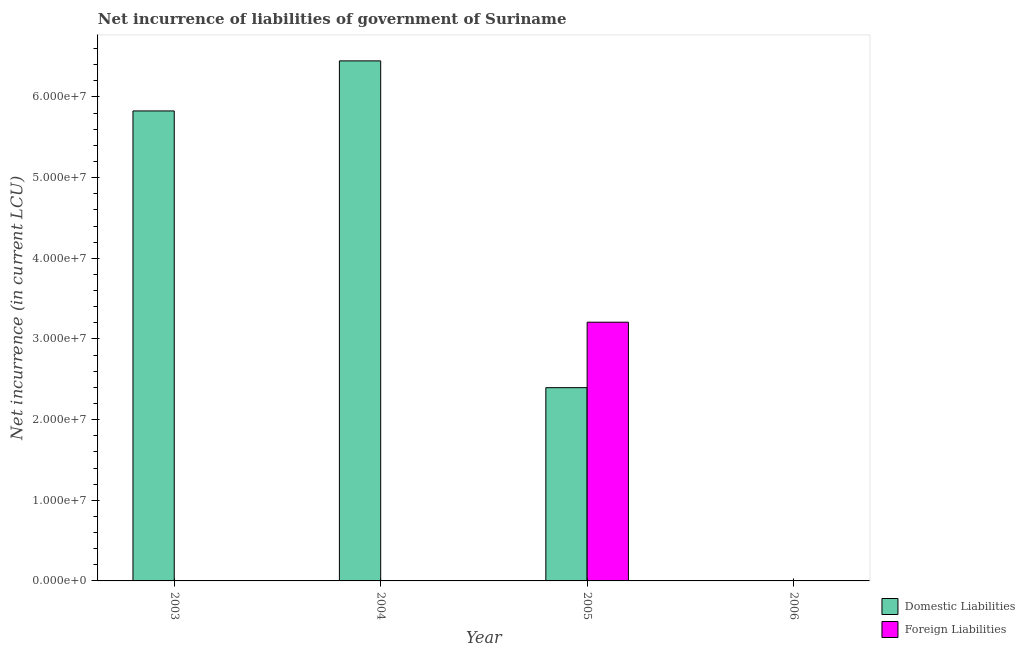What is the label of the 1st group of bars from the left?
Provide a succinct answer. 2003. What is the net incurrence of foreign liabilities in 2004?
Keep it short and to the point. 0. Across all years, what is the maximum net incurrence of domestic liabilities?
Your answer should be very brief. 6.45e+07. Across all years, what is the minimum net incurrence of domestic liabilities?
Your answer should be compact. 0. In which year was the net incurrence of foreign liabilities maximum?
Offer a very short reply. 2005. What is the total net incurrence of foreign liabilities in the graph?
Your response must be concise. 3.21e+07. What is the difference between the net incurrence of domestic liabilities in 2003 and that in 2004?
Your answer should be very brief. -6.21e+06. What is the difference between the net incurrence of domestic liabilities in 2006 and the net incurrence of foreign liabilities in 2004?
Your answer should be compact. -6.45e+07. What is the average net incurrence of domestic liabilities per year?
Make the answer very short. 3.67e+07. In the year 2003, what is the difference between the net incurrence of domestic liabilities and net incurrence of foreign liabilities?
Your answer should be very brief. 0. What is the ratio of the net incurrence of domestic liabilities in 2004 to that in 2005?
Make the answer very short. 2.69. Is the difference between the net incurrence of domestic liabilities in 2003 and 2005 greater than the difference between the net incurrence of foreign liabilities in 2003 and 2005?
Your answer should be compact. No. What is the difference between the highest and the second highest net incurrence of domestic liabilities?
Make the answer very short. 6.21e+06. What is the difference between the highest and the lowest net incurrence of foreign liabilities?
Provide a succinct answer. 3.21e+07. How many bars are there?
Your answer should be very brief. 4. How many years are there in the graph?
Give a very brief answer. 4. Does the graph contain grids?
Provide a succinct answer. No. How many legend labels are there?
Provide a short and direct response. 2. How are the legend labels stacked?
Your answer should be very brief. Vertical. What is the title of the graph?
Give a very brief answer. Net incurrence of liabilities of government of Suriname. Does "Netherlands" appear as one of the legend labels in the graph?
Your response must be concise. No. What is the label or title of the X-axis?
Make the answer very short. Year. What is the label or title of the Y-axis?
Give a very brief answer. Net incurrence (in current LCU). What is the Net incurrence (in current LCU) in Domestic Liabilities in 2003?
Your answer should be very brief. 5.83e+07. What is the Net incurrence (in current LCU) of Foreign Liabilities in 2003?
Offer a very short reply. 0. What is the Net incurrence (in current LCU) in Domestic Liabilities in 2004?
Keep it short and to the point. 6.45e+07. What is the Net incurrence (in current LCU) of Foreign Liabilities in 2004?
Your answer should be very brief. 0. What is the Net incurrence (in current LCU) of Domestic Liabilities in 2005?
Provide a succinct answer. 2.40e+07. What is the Net incurrence (in current LCU) of Foreign Liabilities in 2005?
Your answer should be very brief. 3.21e+07. What is the Net incurrence (in current LCU) in Foreign Liabilities in 2006?
Make the answer very short. 0. Across all years, what is the maximum Net incurrence (in current LCU) of Domestic Liabilities?
Your response must be concise. 6.45e+07. Across all years, what is the maximum Net incurrence (in current LCU) in Foreign Liabilities?
Provide a short and direct response. 3.21e+07. Across all years, what is the minimum Net incurrence (in current LCU) of Foreign Liabilities?
Ensure brevity in your answer.  0. What is the total Net incurrence (in current LCU) of Domestic Liabilities in the graph?
Offer a very short reply. 1.47e+08. What is the total Net incurrence (in current LCU) of Foreign Liabilities in the graph?
Give a very brief answer. 3.21e+07. What is the difference between the Net incurrence (in current LCU) of Domestic Liabilities in 2003 and that in 2004?
Give a very brief answer. -6.21e+06. What is the difference between the Net incurrence (in current LCU) in Domestic Liabilities in 2003 and that in 2005?
Your response must be concise. 3.43e+07. What is the difference between the Net incurrence (in current LCU) in Domestic Liabilities in 2004 and that in 2005?
Your answer should be very brief. 4.05e+07. What is the difference between the Net incurrence (in current LCU) of Domestic Liabilities in 2003 and the Net incurrence (in current LCU) of Foreign Liabilities in 2005?
Give a very brief answer. 2.62e+07. What is the difference between the Net incurrence (in current LCU) in Domestic Liabilities in 2004 and the Net incurrence (in current LCU) in Foreign Liabilities in 2005?
Your answer should be very brief. 3.24e+07. What is the average Net incurrence (in current LCU) of Domestic Liabilities per year?
Your response must be concise. 3.67e+07. What is the average Net incurrence (in current LCU) of Foreign Liabilities per year?
Ensure brevity in your answer.  8.02e+06. In the year 2005, what is the difference between the Net incurrence (in current LCU) in Domestic Liabilities and Net incurrence (in current LCU) in Foreign Liabilities?
Make the answer very short. -8.12e+06. What is the ratio of the Net incurrence (in current LCU) of Domestic Liabilities in 2003 to that in 2004?
Provide a short and direct response. 0.9. What is the ratio of the Net incurrence (in current LCU) of Domestic Liabilities in 2003 to that in 2005?
Your answer should be very brief. 2.43. What is the ratio of the Net incurrence (in current LCU) in Domestic Liabilities in 2004 to that in 2005?
Provide a short and direct response. 2.69. What is the difference between the highest and the second highest Net incurrence (in current LCU) in Domestic Liabilities?
Ensure brevity in your answer.  6.21e+06. What is the difference between the highest and the lowest Net incurrence (in current LCU) in Domestic Liabilities?
Your answer should be compact. 6.45e+07. What is the difference between the highest and the lowest Net incurrence (in current LCU) in Foreign Liabilities?
Offer a very short reply. 3.21e+07. 